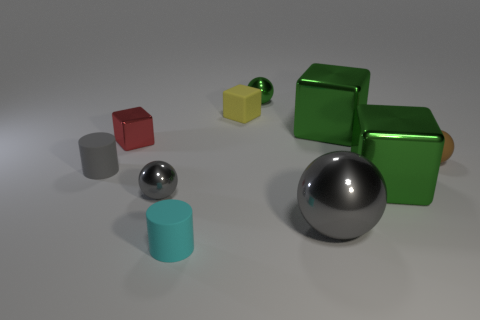Subtract all large green metal spheres. Subtract all large green things. How many objects are left? 8 Add 3 small red metallic things. How many small red metallic things are left? 4 Add 5 tiny green metal balls. How many tiny green metal balls exist? 6 Subtract all gray cylinders. How many cylinders are left? 1 Subtract all shiny cubes. How many cubes are left? 1 Subtract 0 blue cubes. How many objects are left? 10 Subtract all cylinders. How many objects are left? 8 Subtract 2 cylinders. How many cylinders are left? 0 Subtract all brown blocks. Subtract all green cylinders. How many blocks are left? 4 Subtract all green blocks. How many gray balls are left? 2 